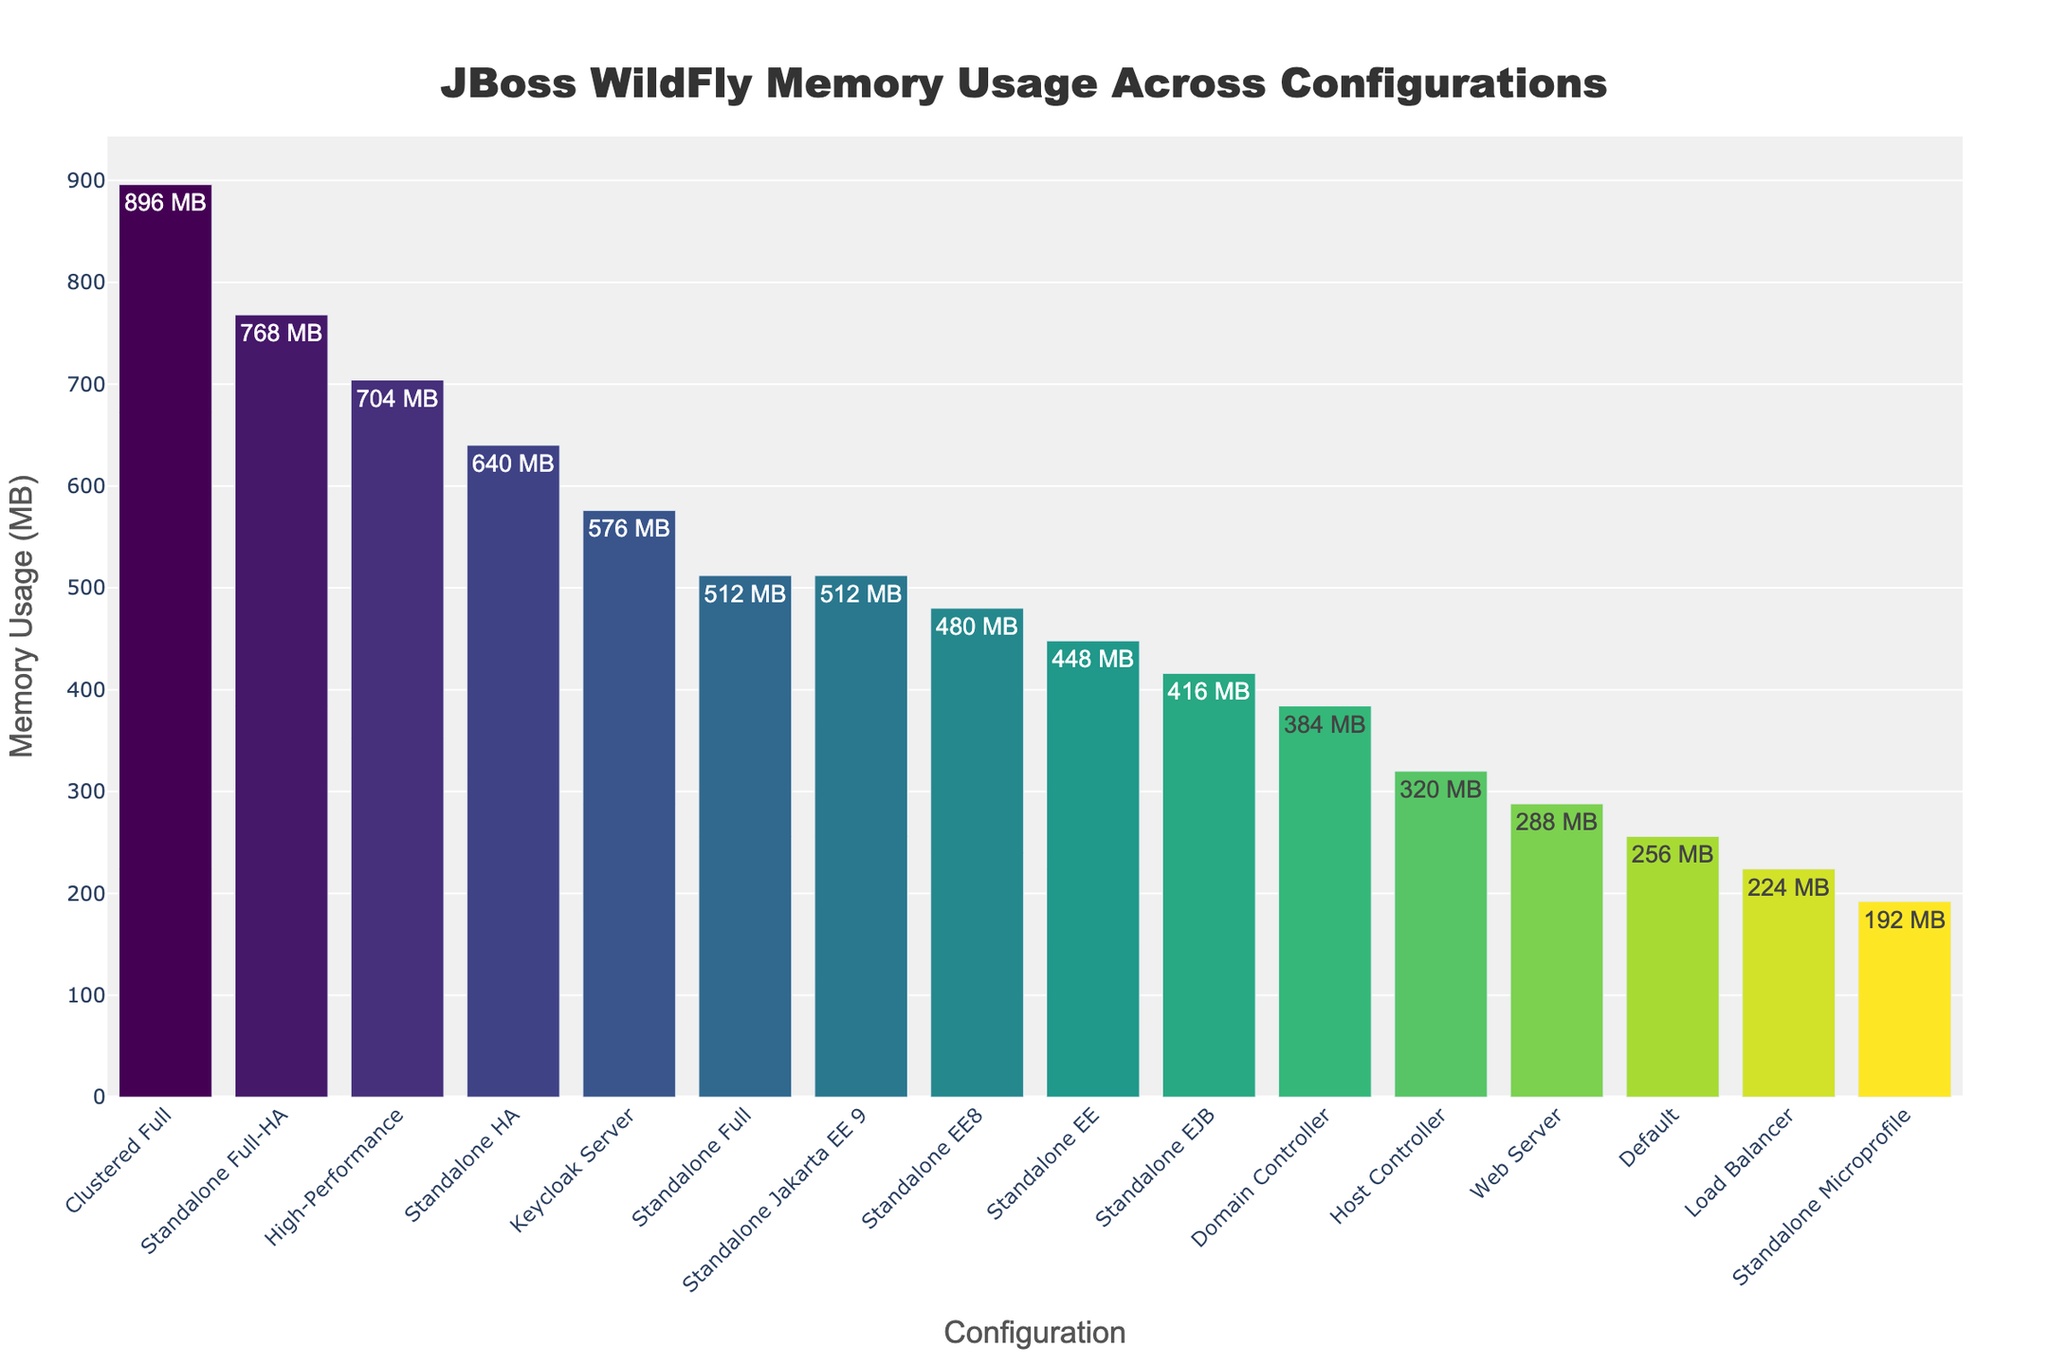What's the configuration with the highest memory usage? The highest bar in the chart visually represents the configuration with the highest memory usage. By inspecting the chart, it's clear that "Clustered Full" has the tallest bar.
Answer: Clustered Full Which configuration consumes less memory, Load Balancer or Web Server? By comparing the heights of the bars for "Load Balancer" and "Web Server," we see that the bar for "Load Balancer" is shorter, which indicates it consumes less memory.
Answer: Load Balancer What's the total memory usage of 'High-Performance' and 'Standalone EJB' configurations combined? The memory usage values for 'High-Performance' and 'Standalone EJB' are 704 MB and 416 MB respectively. Adding these values gives 704 + 416 = 1120 MB.
Answer: 1120 MB How much more memory does 'Standalone Full-HA' use compared to 'Standalone Full'? The memory usage for 'Standalone Full-HA' is 768 MB, and for 'Standalone Full', it is 512 MB. The difference is 768 - 512 = 256 MB.
Answer: 256 MB Which configurations have memory usage greater than 500 MB? To identify the configurations with memory usage greater than 500 MB, we look for bars that extend above the 500 MB mark. These configurations are 'Standalone Full-HA', 'Clustered Full', and 'Keycloak Server'.
Answer: Standalone Full-HA, Clustered Full, Keycloak Server What is the average memory usage of all configurations? Sum the memory usage values of all configurations: 256 + 512 + 768 + 640 + 384 + 320 + 192 + 448 + 480 + 512 + 896 + 224 + 288 + 576 + 416 + 704 = 8628 MB. There are 16 configurations, so the average is 8628 / 16 = 539.25 MB.
Answer: 539.25 MB Which configuration uses the least memory? The shortest bar in the chart represents the configuration with the least memory usage. Visually, this is the 'Standalone Microprofile' configuration.
Answer: Standalone Microprofile What's the median memory usage value among the configurations? First, list all memory usage values in ascending order: 192, 224, 256, 288, 320, 384, 416, 448, 480, 512, 512, 576, 640, 704, 768, 896. The median is the average of the 8th and 9th values: (448 + 480) / 2 = 464 MB.
Answer: 464 MB 